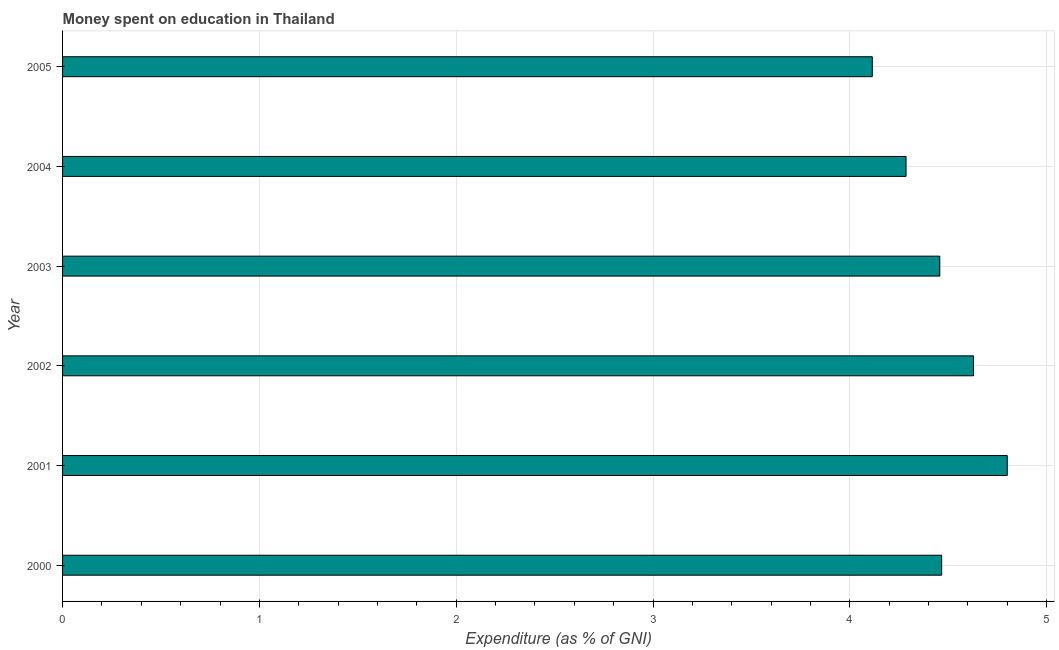Does the graph contain grids?
Provide a short and direct response. Yes. What is the title of the graph?
Your answer should be compact. Money spent on education in Thailand. What is the label or title of the X-axis?
Your answer should be very brief. Expenditure (as % of GNI). What is the label or title of the Y-axis?
Provide a short and direct response. Year. What is the expenditure on education in 2004?
Your answer should be compact. 4.29. Across all years, what is the minimum expenditure on education?
Your answer should be compact. 4.11. What is the sum of the expenditure on education?
Make the answer very short. 26.75. What is the difference between the expenditure on education in 2001 and 2003?
Make the answer very short. 0.34. What is the average expenditure on education per year?
Provide a succinct answer. 4.46. What is the median expenditure on education?
Ensure brevity in your answer.  4.46. Do a majority of the years between 2002 and 2001 (inclusive) have expenditure on education greater than 2.2 %?
Provide a short and direct response. No. What is the ratio of the expenditure on education in 2000 to that in 2004?
Give a very brief answer. 1.04. Is the difference between the expenditure on education in 2002 and 2004 greater than the difference between any two years?
Your answer should be compact. No. What is the difference between the highest and the second highest expenditure on education?
Your answer should be very brief. 0.17. What is the difference between the highest and the lowest expenditure on education?
Your answer should be very brief. 0.69. In how many years, is the expenditure on education greater than the average expenditure on education taken over all years?
Keep it short and to the point. 3. How many bars are there?
Make the answer very short. 6. Are the values on the major ticks of X-axis written in scientific E-notation?
Offer a very short reply. No. What is the Expenditure (as % of GNI) of 2000?
Your answer should be compact. 4.47. What is the Expenditure (as % of GNI) of 2001?
Give a very brief answer. 4.8. What is the Expenditure (as % of GNI) in 2002?
Keep it short and to the point. 4.63. What is the Expenditure (as % of GNI) of 2003?
Your response must be concise. 4.46. What is the Expenditure (as % of GNI) of 2004?
Provide a short and direct response. 4.29. What is the Expenditure (as % of GNI) of 2005?
Ensure brevity in your answer.  4.11. What is the difference between the Expenditure (as % of GNI) in 2000 and 2001?
Your answer should be compact. -0.33. What is the difference between the Expenditure (as % of GNI) in 2000 and 2002?
Make the answer very short. -0.16. What is the difference between the Expenditure (as % of GNI) in 2000 and 2003?
Your answer should be compact. 0.01. What is the difference between the Expenditure (as % of GNI) in 2000 and 2004?
Make the answer very short. 0.18. What is the difference between the Expenditure (as % of GNI) in 2000 and 2005?
Ensure brevity in your answer.  0.35. What is the difference between the Expenditure (as % of GNI) in 2001 and 2002?
Offer a terse response. 0.17. What is the difference between the Expenditure (as % of GNI) in 2001 and 2003?
Your response must be concise. 0.34. What is the difference between the Expenditure (as % of GNI) in 2001 and 2004?
Offer a terse response. 0.51. What is the difference between the Expenditure (as % of GNI) in 2001 and 2005?
Make the answer very short. 0.69. What is the difference between the Expenditure (as % of GNI) in 2002 and 2003?
Offer a terse response. 0.17. What is the difference between the Expenditure (as % of GNI) in 2002 and 2004?
Provide a succinct answer. 0.34. What is the difference between the Expenditure (as % of GNI) in 2002 and 2005?
Make the answer very short. 0.51. What is the difference between the Expenditure (as % of GNI) in 2003 and 2004?
Provide a succinct answer. 0.17. What is the difference between the Expenditure (as % of GNI) in 2003 and 2005?
Give a very brief answer. 0.34. What is the difference between the Expenditure (as % of GNI) in 2004 and 2005?
Your response must be concise. 0.17. What is the ratio of the Expenditure (as % of GNI) in 2000 to that in 2003?
Ensure brevity in your answer.  1. What is the ratio of the Expenditure (as % of GNI) in 2000 to that in 2004?
Provide a short and direct response. 1.04. What is the ratio of the Expenditure (as % of GNI) in 2000 to that in 2005?
Your answer should be very brief. 1.09. What is the ratio of the Expenditure (as % of GNI) in 2001 to that in 2003?
Provide a short and direct response. 1.08. What is the ratio of the Expenditure (as % of GNI) in 2001 to that in 2004?
Keep it short and to the point. 1.12. What is the ratio of the Expenditure (as % of GNI) in 2001 to that in 2005?
Make the answer very short. 1.17. What is the ratio of the Expenditure (as % of GNI) in 2002 to that in 2003?
Ensure brevity in your answer.  1.04. What is the ratio of the Expenditure (as % of GNI) in 2002 to that in 2005?
Offer a terse response. 1.12. What is the ratio of the Expenditure (as % of GNI) in 2003 to that in 2005?
Make the answer very short. 1.08. What is the ratio of the Expenditure (as % of GNI) in 2004 to that in 2005?
Offer a terse response. 1.04. 